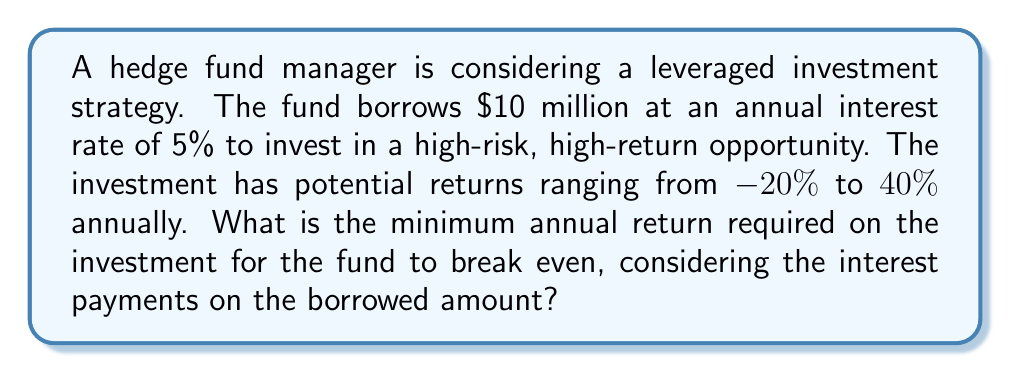Can you solve this math problem? Let's approach this step-by-step:

1) First, we need to calculate the annual interest payment on the borrowed amount:
   Interest = Principal × Rate
   $$ \text{Interest} = \$10,000,000 \times 0.05 = \$500,000 $$

2) To break even, the return on investment must equal the interest payment:
   $$ \text{Return on Investment} = \text{Interest Payment} $$

3) Let $x$ be the required return rate (as a decimal). Then:
   $$ 10,000,000x = 500,000 $$

4) Solve for $x$:
   $$ x = \frac{500,000}{10,000,000} = 0.05 $$

5) Convert to a percentage:
   $$ 0.05 \times 100\% = 5\% $$

Therefore, the fund needs to earn at least a 5% annual return on the investment to break even.
Answer: 5% 